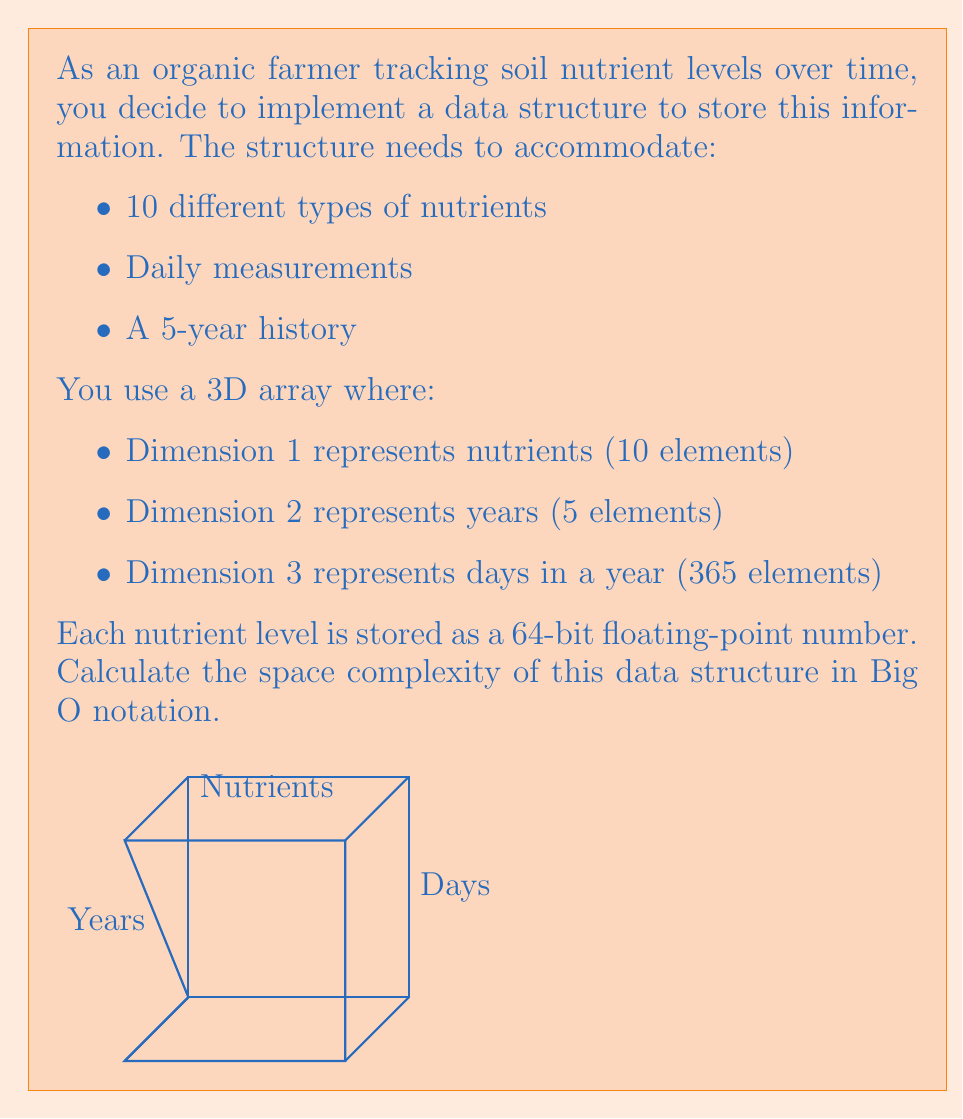Give your solution to this math problem. Let's break down the problem and calculate the space complexity step by step:

1) First, we need to determine the total number of elements in our 3D array:
   $$ \text{Total elements} = 10 \times 5 \times 365 = 18,250 $$

2) Each element is a 64-bit (8-byte) floating-point number. So the total space required is:
   $$ \text{Total space} = 18,250 \times 8 \text{ bytes} = 146,000 \text{ bytes} $$

3) In Big O notation, we're interested in how the space requirements grow with respect to the input size. In this case, we have three variables:
   - $n$: number of nutrients
   - $y$: number of years
   - $d$: number of days per year

4) The space required can be expressed as a function of these variables:
   $$ S(n, y, d) = n \times y \times d \times 8 \text{ bytes} $$

5) In Big O notation, we drop constant factors and focus on the growth rate. Therefore, the space complexity is:
   $$ O(n \times y \times d) $$

6) Since $y$ (5 years) and $d$ (365 days) are fixed in this scenario, they can be considered constants. In Big O notation, we typically express complexity in terms of the variable input, which in this case is $n$ (number of nutrients).

7) With $y$ and $d$ as constants, the space complexity simplifies to:
   $$ O(n) $$

This means the space requirement grows linearly with the number of nutrients being tracked.
Answer: $O(n)$ 